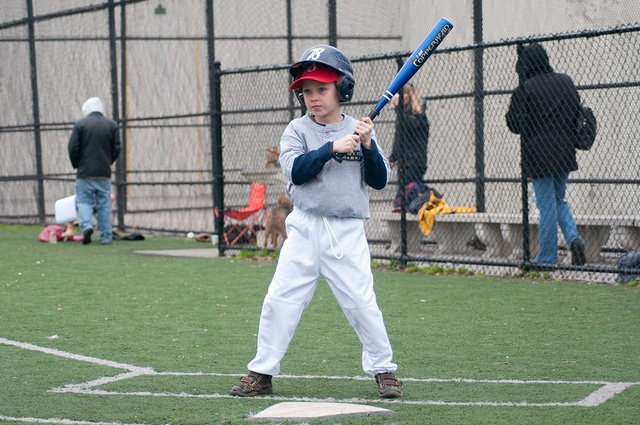Describe the objects in this image and their specific colors. I can see people in darkgray, lavender, and black tones, people in darkgray, black, blue, darkblue, and gray tones, bench in darkgray, gray, black, and lightgray tones, people in darkgray, black, and gray tones, and people in darkgray, black, gray, and darkblue tones in this image. 